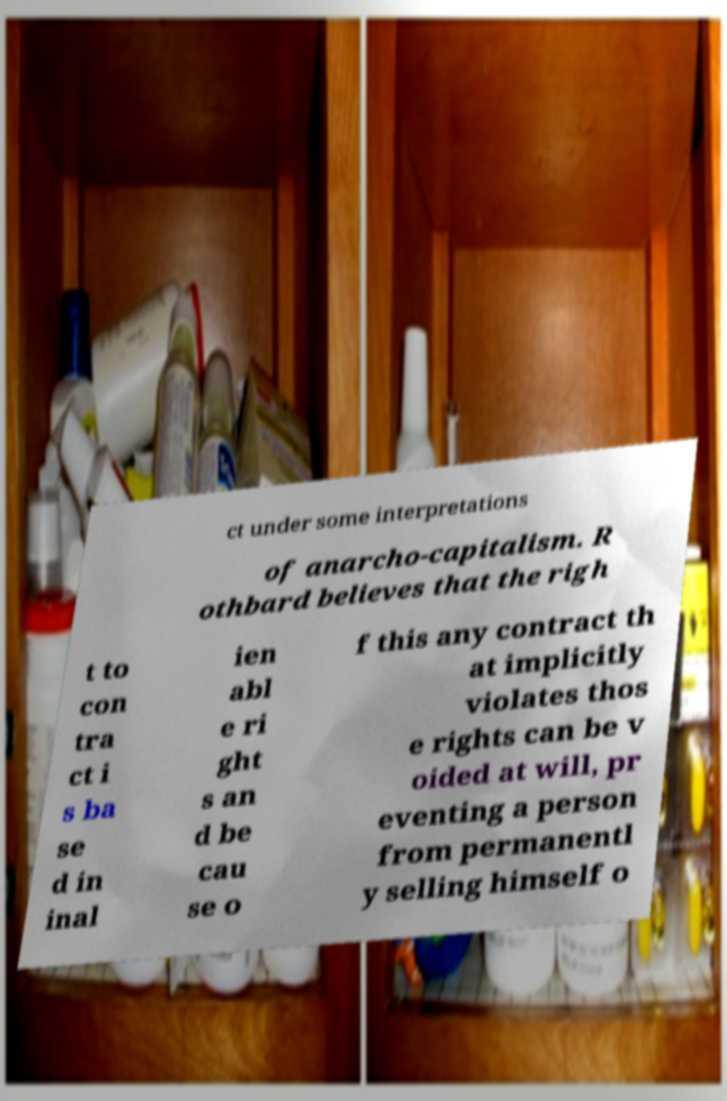For documentation purposes, I need the text within this image transcribed. Could you provide that? ct under some interpretations of anarcho-capitalism. R othbard believes that the righ t to con tra ct i s ba se d in inal ien abl e ri ght s an d be cau se o f this any contract th at implicitly violates thos e rights can be v oided at will, pr eventing a person from permanentl y selling himself o 